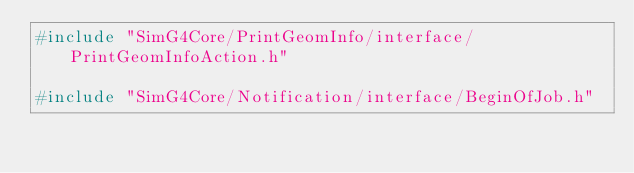<code> <loc_0><loc_0><loc_500><loc_500><_C++_>#include "SimG4Core/PrintGeomInfo/interface/PrintGeomInfoAction.h"

#include "SimG4Core/Notification/interface/BeginOfJob.h"</code> 